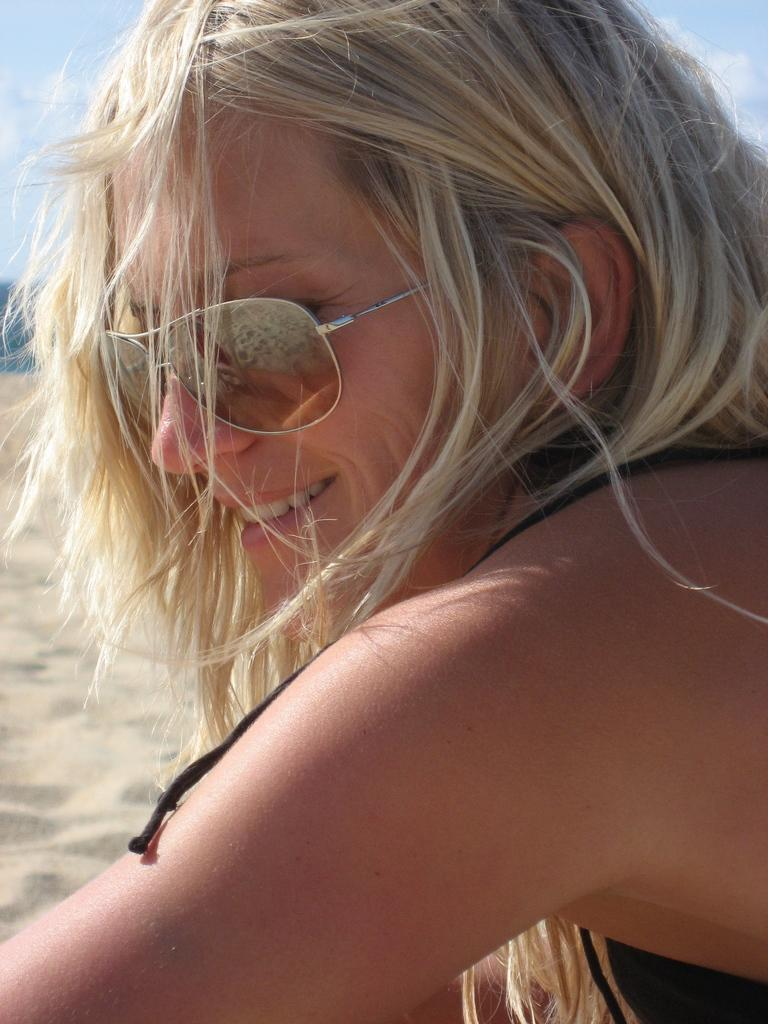What is the main subject of the picture? The main subject of the picture is a woman. What is the woman doing in the picture? The woman is smiling in the picture. What accessory is the woman wearing in the picture? The woman is wearing goggles in the picture. What type of knot is the woman using to secure her apparatus in the image? There is no apparatus or knot present in the image; it features a woman wearing goggles and smiling. 